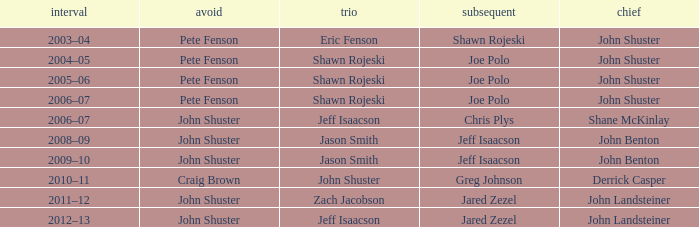Which season has Zach Jacobson in third? 2011–12. 